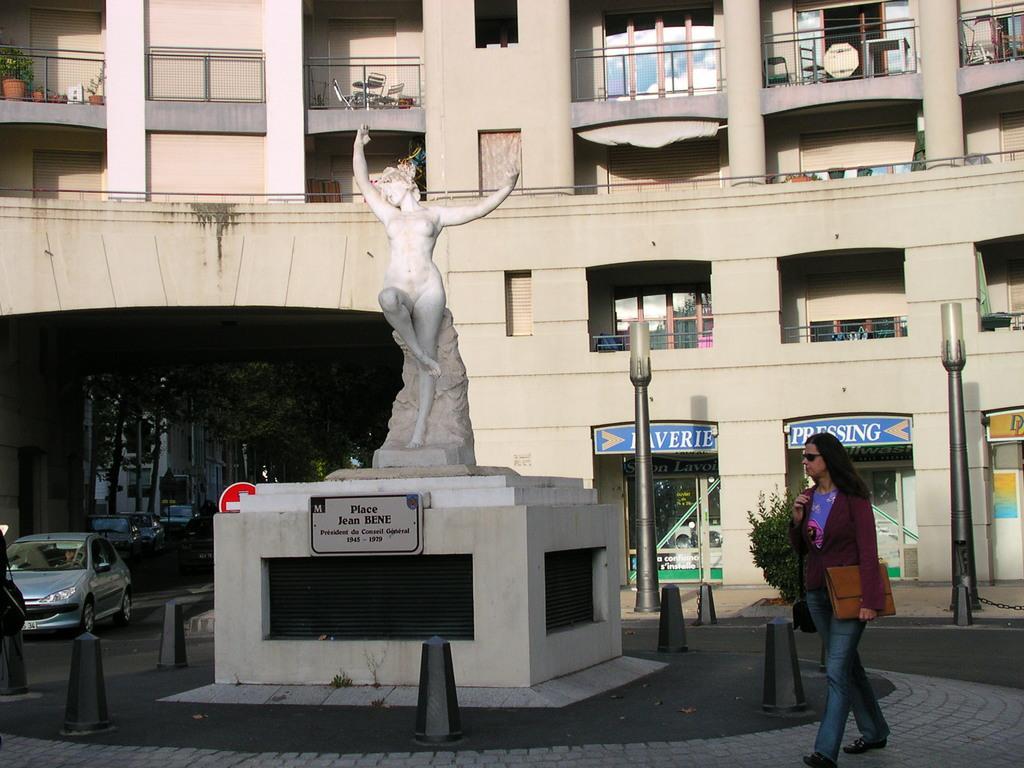Can you describe this image briefly? In this image, we can see a statue on the cement stone which is in front of the building. There is a road in between divider cones. There are street poles on the right side of the image. There is a car in the bottom left of the image. There is a in the bottom right of the image wearing a bag and holding a file with her hand. 